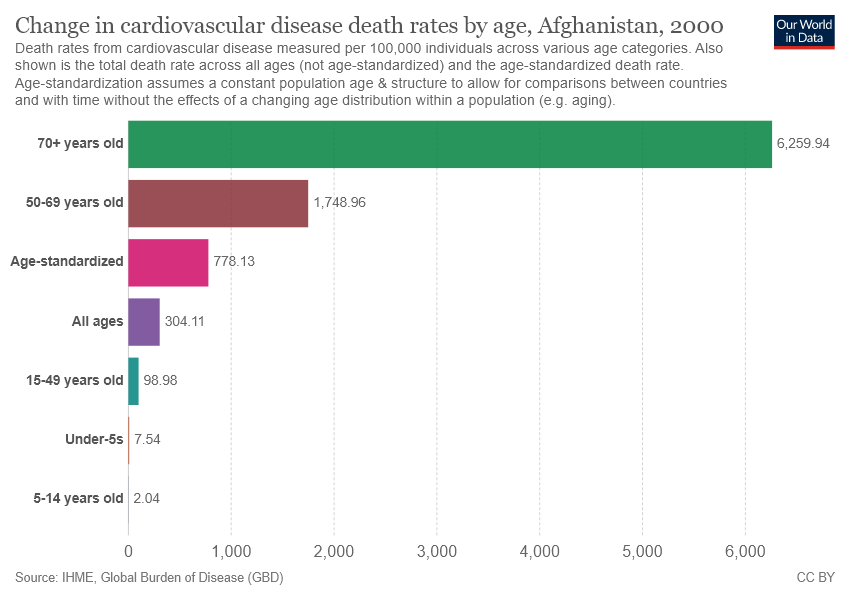Mention a couple of crucial points in this snapshot. The largest bar is 70 years old or older. The sum of the smallest two bars is 9.58. 